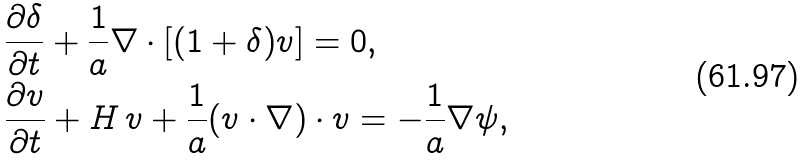<formula> <loc_0><loc_0><loc_500><loc_500>& \frac { \partial \delta } { \partial t } + \frac { 1 } { a } \nabla \cdot [ ( 1 + \delta ) v ] = 0 , \\ & \frac { \partial v } { \partial t } + H \, v + \frac { 1 } { a } ( v \cdot \nabla ) \cdot v = - \frac { 1 } { a } \nabla \psi ,</formula> 